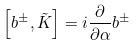<formula> <loc_0><loc_0><loc_500><loc_500>\left [ b ^ { \pm } , \tilde { K } \right ] = i \frac { \partial } { \partial \alpha } b ^ { \pm }</formula> 